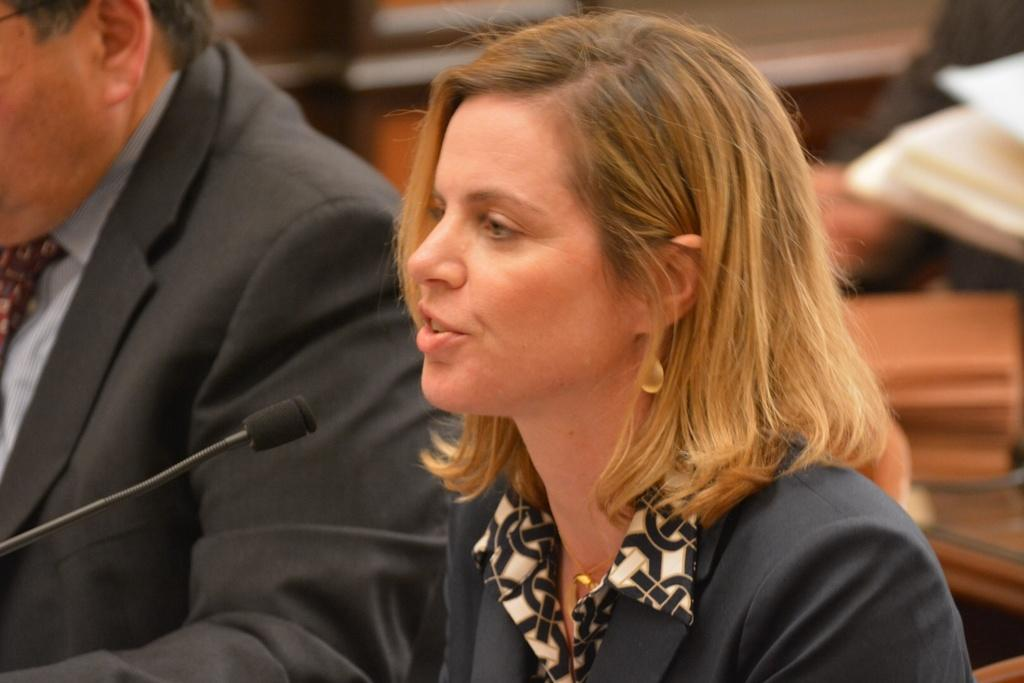How many people are sitting in the image? There are two people sitting in the image. What object is present that is typically used for amplifying sound? There is a microphone in the image. What can be seen on the table in the image? There are objects on a table in the image. What is the woman doing in the image? The woman is sitting on a chair and talking in the image. How many cows are present on the farm in the image? There is no farm or cows present in the image. What is the amount of agreement between the two people in the image? The provided facts do not give any information about the level of agreement between the two people in the image. 